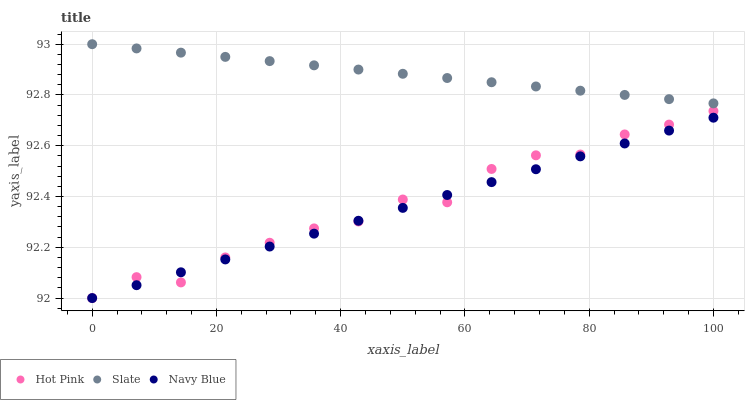Does Navy Blue have the minimum area under the curve?
Answer yes or no. Yes. Does Slate have the maximum area under the curve?
Answer yes or no. Yes. Does Hot Pink have the minimum area under the curve?
Answer yes or no. No. Does Hot Pink have the maximum area under the curve?
Answer yes or no. No. Is Navy Blue the smoothest?
Answer yes or no. Yes. Is Hot Pink the roughest?
Answer yes or no. Yes. Is Slate the smoothest?
Answer yes or no. No. Is Slate the roughest?
Answer yes or no. No. Does Navy Blue have the lowest value?
Answer yes or no. Yes. Does Slate have the lowest value?
Answer yes or no. No. Does Slate have the highest value?
Answer yes or no. Yes. Does Hot Pink have the highest value?
Answer yes or no. No. Is Hot Pink less than Slate?
Answer yes or no. Yes. Is Slate greater than Hot Pink?
Answer yes or no. Yes. Does Hot Pink intersect Navy Blue?
Answer yes or no. Yes. Is Hot Pink less than Navy Blue?
Answer yes or no. No. Is Hot Pink greater than Navy Blue?
Answer yes or no. No. Does Hot Pink intersect Slate?
Answer yes or no. No. 